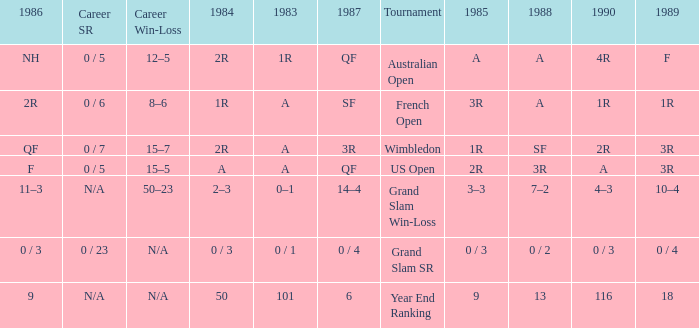What tournament has 0 / 5 as career SR and A as 1983? US Open. 